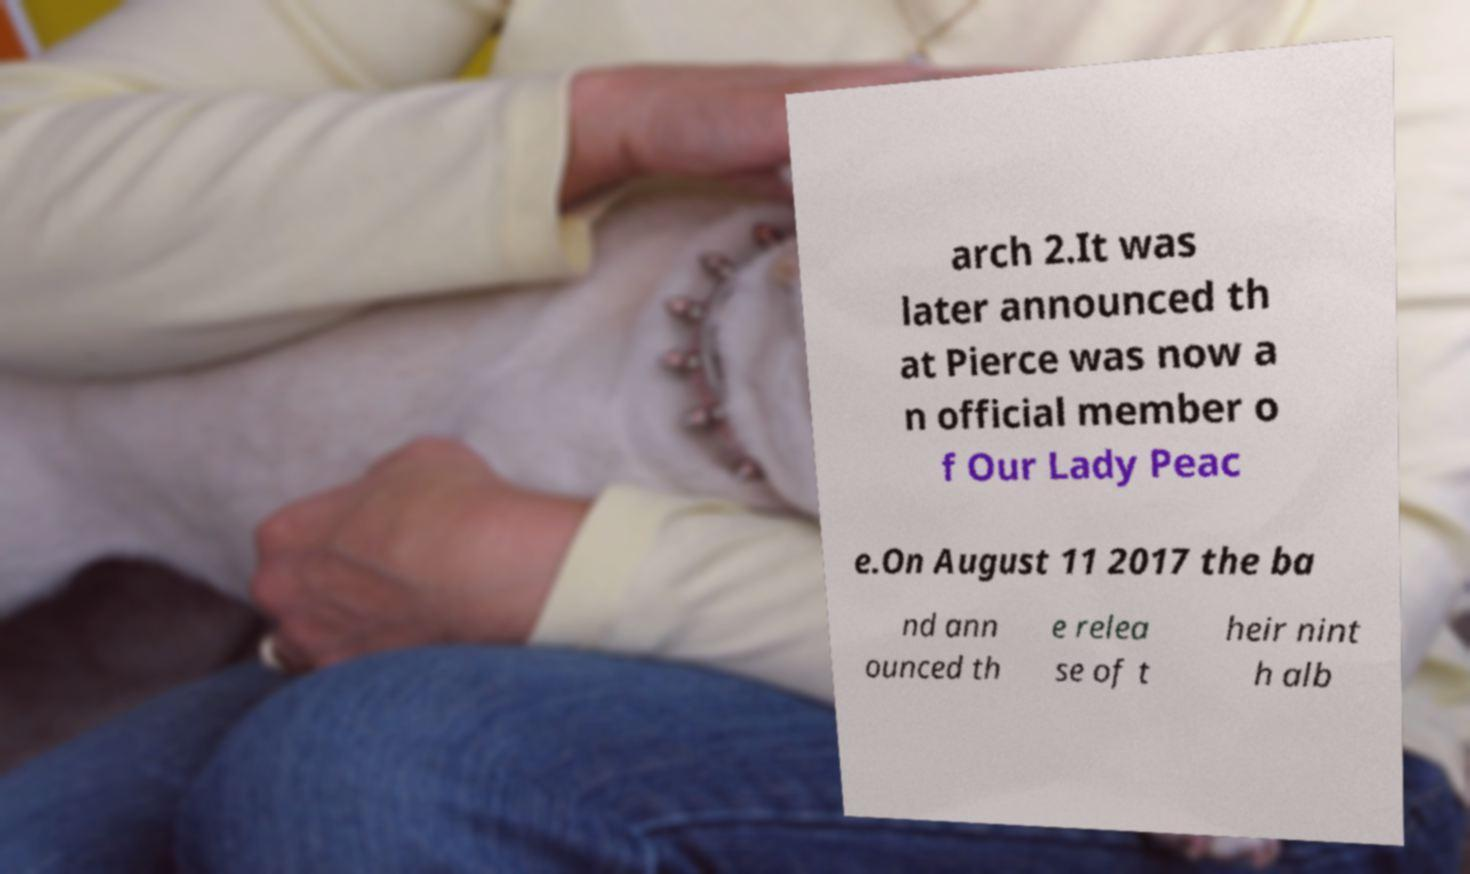Could you extract and type out the text from this image? arch 2.It was later announced th at Pierce was now a n official member o f Our Lady Peac e.On August 11 2017 the ba nd ann ounced th e relea se of t heir nint h alb 